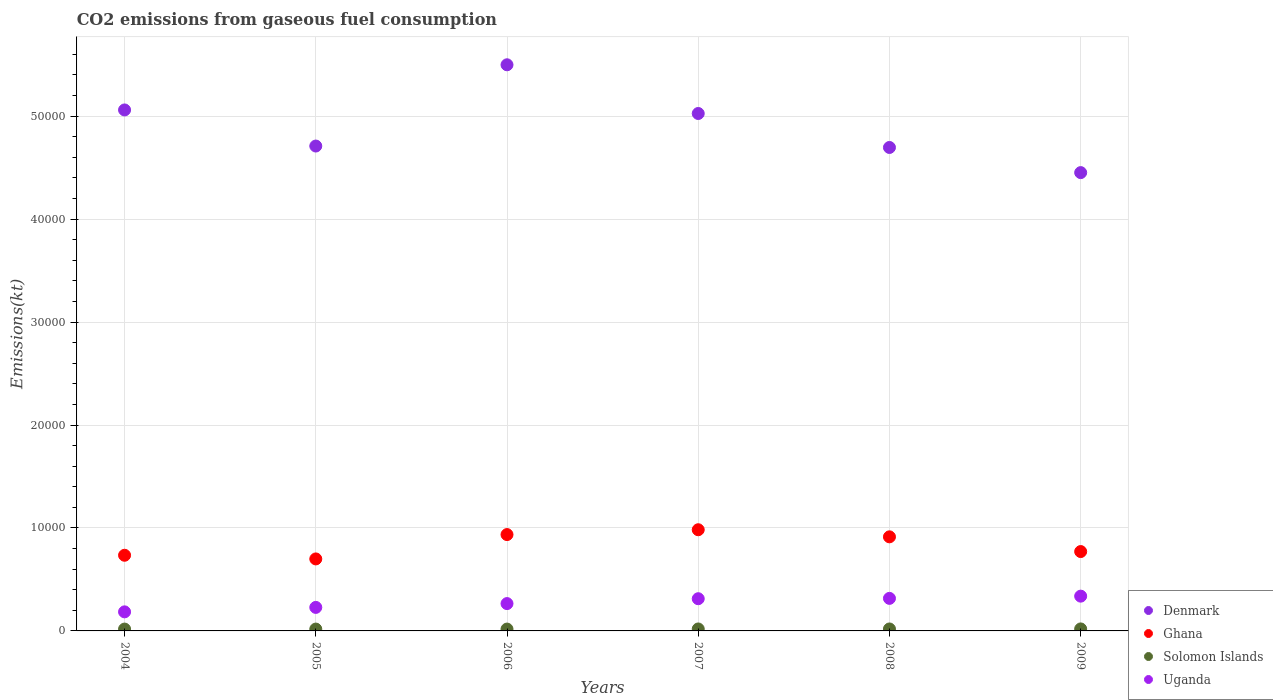How many different coloured dotlines are there?
Your response must be concise. 4. What is the amount of CO2 emitted in Solomon Islands in 2008?
Provide a short and direct response. 190.68. Across all years, what is the maximum amount of CO2 emitted in Uganda?
Ensure brevity in your answer.  3377.31. Across all years, what is the minimum amount of CO2 emitted in Uganda?
Ensure brevity in your answer.  1851.84. What is the total amount of CO2 emitted in Denmark in the graph?
Offer a very short reply. 2.94e+05. What is the difference between the amount of CO2 emitted in Denmark in 2006 and that in 2009?
Make the answer very short. 1.05e+04. What is the difference between the amount of CO2 emitted in Uganda in 2009 and the amount of CO2 emitted in Solomon Islands in 2007?
Offer a very short reply. 3186.62. What is the average amount of CO2 emitted in Denmark per year?
Give a very brief answer. 4.91e+04. In the year 2004, what is the difference between the amount of CO2 emitted in Uganda and amount of CO2 emitted in Denmark?
Provide a short and direct response. -4.87e+04. What is the ratio of the amount of CO2 emitted in Denmark in 2005 to that in 2006?
Your answer should be compact. 0.86. What is the difference between the highest and the second highest amount of CO2 emitted in Uganda?
Make the answer very short. 216.35. What is the difference between the highest and the lowest amount of CO2 emitted in Uganda?
Provide a succinct answer. 1525.47. In how many years, is the amount of CO2 emitted in Uganda greater than the average amount of CO2 emitted in Uganda taken over all years?
Offer a terse response. 3. Is it the case that in every year, the sum of the amount of CO2 emitted in Ghana and amount of CO2 emitted in Denmark  is greater than the sum of amount of CO2 emitted in Solomon Islands and amount of CO2 emitted in Uganda?
Your answer should be very brief. No. Is it the case that in every year, the sum of the amount of CO2 emitted in Solomon Islands and amount of CO2 emitted in Denmark  is greater than the amount of CO2 emitted in Ghana?
Give a very brief answer. Yes. Is the amount of CO2 emitted in Denmark strictly less than the amount of CO2 emitted in Solomon Islands over the years?
Offer a terse response. No. How many dotlines are there?
Ensure brevity in your answer.  4. What is the difference between two consecutive major ticks on the Y-axis?
Give a very brief answer. 10000. Does the graph contain any zero values?
Keep it short and to the point. No. Where does the legend appear in the graph?
Your answer should be compact. Bottom right. How many legend labels are there?
Your answer should be very brief. 4. How are the legend labels stacked?
Your response must be concise. Vertical. What is the title of the graph?
Provide a short and direct response. CO2 emissions from gaseous fuel consumption. Does "Ghana" appear as one of the legend labels in the graph?
Make the answer very short. Yes. What is the label or title of the X-axis?
Keep it short and to the point. Years. What is the label or title of the Y-axis?
Provide a succinct answer. Emissions(kt). What is the Emissions(kt) in Denmark in 2004?
Keep it short and to the point. 5.06e+04. What is the Emissions(kt) in Ghana in 2004?
Provide a succinct answer. 7348.67. What is the Emissions(kt) in Solomon Islands in 2004?
Offer a very short reply. 179.68. What is the Emissions(kt) of Uganda in 2004?
Keep it short and to the point. 1851.84. What is the Emissions(kt) of Denmark in 2005?
Provide a succinct answer. 4.71e+04. What is the Emissions(kt) in Ghana in 2005?
Ensure brevity in your answer.  6992.97. What is the Emissions(kt) of Solomon Islands in 2005?
Offer a very short reply. 179.68. What is the Emissions(kt) of Uganda in 2005?
Your answer should be compact. 2284.54. What is the Emissions(kt) of Denmark in 2006?
Ensure brevity in your answer.  5.50e+04. What is the Emissions(kt) of Ghana in 2006?
Your response must be concise. 9358.18. What is the Emissions(kt) in Solomon Islands in 2006?
Ensure brevity in your answer.  179.68. What is the Emissions(kt) of Uganda in 2006?
Give a very brief answer. 2654.91. What is the Emissions(kt) of Denmark in 2007?
Make the answer very short. 5.03e+04. What is the Emissions(kt) in Ghana in 2007?
Offer a terse response. 9827.56. What is the Emissions(kt) of Solomon Islands in 2007?
Make the answer very short. 190.68. What is the Emissions(kt) in Uganda in 2007?
Make the answer very short. 3127.95. What is the Emissions(kt) of Denmark in 2008?
Offer a very short reply. 4.70e+04. What is the Emissions(kt) in Ghana in 2008?
Make the answer very short. 9138.16. What is the Emissions(kt) in Solomon Islands in 2008?
Make the answer very short. 190.68. What is the Emissions(kt) in Uganda in 2008?
Your answer should be very brief. 3160.95. What is the Emissions(kt) in Denmark in 2009?
Give a very brief answer. 4.45e+04. What is the Emissions(kt) in Ghana in 2009?
Ensure brevity in your answer.  7708.03. What is the Emissions(kt) in Solomon Islands in 2009?
Make the answer very short. 194.35. What is the Emissions(kt) of Uganda in 2009?
Make the answer very short. 3377.31. Across all years, what is the maximum Emissions(kt) of Denmark?
Offer a very short reply. 5.50e+04. Across all years, what is the maximum Emissions(kt) in Ghana?
Your answer should be very brief. 9827.56. Across all years, what is the maximum Emissions(kt) of Solomon Islands?
Make the answer very short. 194.35. Across all years, what is the maximum Emissions(kt) in Uganda?
Provide a succinct answer. 3377.31. Across all years, what is the minimum Emissions(kt) in Denmark?
Provide a succinct answer. 4.45e+04. Across all years, what is the minimum Emissions(kt) of Ghana?
Give a very brief answer. 6992.97. Across all years, what is the minimum Emissions(kt) in Solomon Islands?
Provide a short and direct response. 179.68. Across all years, what is the minimum Emissions(kt) of Uganda?
Your answer should be compact. 1851.84. What is the total Emissions(kt) in Denmark in the graph?
Make the answer very short. 2.94e+05. What is the total Emissions(kt) of Ghana in the graph?
Give a very brief answer. 5.04e+04. What is the total Emissions(kt) of Solomon Islands in the graph?
Your response must be concise. 1114.77. What is the total Emissions(kt) of Uganda in the graph?
Make the answer very short. 1.65e+04. What is the difference between the Emissions(kt) in Denmark in 2004 and that in 2005?
Your answer should be compact. 3505.65. What is the difference between the Emissions(kt) of Ghana in 2004 and that in 2005?
Your answer should be compact. 355.7. What is the difference between the Emissions(kt) in Uganda in 2004 and that in 2005?
Make the answer very short. -432.71. What is the difference between the Emissions(kt) of Denmark in 2004 and that in 2006?
Keep it short and to the point. -4385.73. What is the difference between the Emissions(kt) in Ghana in 2004 and that in 2006?
Provide a succinct answer. -2009.52. What is the difference between the Emissions(kt) in Solomon Islands in 2004 and that in 2006?
Provide a short and direct response. 0. What is the difference between the Emissions(kt) of Uganda in 2004 and that in 2006?
Your answer should be compact. -803.07. What is the difference between the Emissions(kt) in Denmark in 2004 and that in 2007?
Your answer should be very brief. 344.7. What is the difference between the Emissions(kt) in Ghana in 2004 and that in 2007?
Give a very brief answer. -2478.89. What is the difference between the Emissions(kt) of Solomon Islands in 2004 and that in 2007?
Ensure brevity in your answer.  -11. What is the difference between the Emissions(kt) in Uganda in 2004 and that in 2007?
Make the answer very short. -1276.12. What is the difference between the Emissions(kt) of Denmark in 2004 and that in 2008?
Offer a very short reply. 3645. What is the difference between the Emissions(kt) of Ghana in 2004 and that in 2008?
Your answer should be very brief. -1789.5. What is the difference between the Emissions(kt) of Solomon Islands in 2004 and that in 2008?
Ensure brevity in your answer.  -11. What is the difference between the Emissions(kt) in Uganda in 2004 and that in 2008?
Offer a very short reply. -1309.12. What is the difference between the Emissions(kt) in Denmark in 2004 and that in 2009?
Give a very brief answer. 6087.22. What is the difference between the Emissions(kt) in Ghana in 2004 and that in 2009?
Give a very brief answer. -359.37. What is the difference between the Emissions(kt) in Solomon Islands in 2004 and that in 2009?
Give a very brief answer. -14.67. What is the difference between the Emissions(kt) in Uganda in 2004 and that in 2009?
Your answer should be compact. -1525.47. What is the difference between the Emissions(kt) in Denmark in 2005 and that in 2006?
Keep it short and to the point. -7891.38. What is the difference between the Emissions(kt) in Ghana in 2005 and that in 2006?
Provide a short and direct response. -2365.22. What is the difference between the Emissions(kt) of Uganda in 2005 and that in 2006?
Keep it short and to the point. -370.37. What is the difference between the Emissions(kt) of Denmark in 2005 and that in 2007?
Your response must be concise. -3160.95. What is the difference between the Emissions(kt) of Ghana in 2005 and that in 2007?
Provide a short and direct response. -2834.59. What is the difference between the Emissions(kt) of Solomon Islands in 2005 and that in 2007?
Ensure brevity in your answer.  -11. What is the difference between the Emissions(kt) in Uganda in 2005 and that in 2007?
Provide a short and direct response. -843.41. What is the difference between the Emissions(kt) in Denmark in 2005 and that in 2008?
Make the answer very short. 139.35. What is the difference between the Emissions(kt) in Ghana in 2005 and that in 2008?
Offer a terse response. -2145.2. What is the difference between the Emissions(kt) of Solomon Islands in 2005 and that in 2008?
Offer a terse response. -11. What is the difference between the Emissions(kt) in Uganda in 2005 and that in 2008?
Make the answer very short. -876.41. What is the difference between the Emissions(kt) of Denmark in 2005 and that in 2009?
Ensure brevity in your answer.  2581.57. What is the difference between the Emissions(kt) in Ghana in 2005 and that in 2009?
Offer a very short reply. -715.07. What is the difference between the Emissions(kt) of Solomon Islands in 2005 and that in 2009?
Give a very brief answer. -14.67. What is the difference between the Emissions(kt) of Uganda in 2005 and that in 2009?
Offer a terse response. -1092.77. What is the difference between the Emissions(kt) of Denmark in 2006 and that in 2007?
Make the answer very short. 4730.43. What is the difference between the Emissions(kt) of Ghana in 2006 and that in 2007?
Keep it short and to the point. -469.38. What is the difference between the Emissions(kt) in Solomon Islands in 2006 and that in 2007?
Offer a very short reply. -11. What is the difference between the Emissions(kt) of Uganda in 2006 and that in 2007?
Your response must be concise. -473.04. What is the difference between the Emissions(kt) in Denmark in 2006 and that in 2008?
Provide a short and direct response. 8030.73. What is the difference between the Emissions(kt) in Ghana in 2006 and that in 2008?
Offer a terse response. 220.02. What is the difference between the Emissions(kt) of Solomon Islands in 2006 and that in 2008?
Make the answer very short. -11. What is the difference between the Emissions(kt) in Uganda in 2006 and that in 2008?
Offer a terse response. -506.05. What is the difference between the Emissions(kt) in Denmark in 2006 and that in 2009?
Offer a very short reply. 1.05e+04. What is the difference between the Emissions(kt) of Ghana in 2006 and that in 2009?
Offer a terse response. 1650.15. What is the difference between the Emissions(kt) in Solomon Islands in 2006 and that in 2009?
Give a very brief answer. -14.67. What is the difference between the Emissions(kt) of Uganda in 2006 and that in 2009?
Provide a succinct answer. -722.4. What is the difference between the Emissions(kt) of Denmark in 2007 and that in 2008?
Your answer should be very brief. 3300.3. What is the difference between the Emissions(kt) of Ghana in 2007 and that in 2008?
Offer a very short reply. 689.4. What is the difference between the Emissions(kt) in Uganda in 2007 and that in 2008?
Offer a terse response. -33. What is the difference between the Emissions(kt) in Denmark in 2007 and that in 2009?
Your response must be concise. 5742.52. What is the difference between the Emissions(kt) in Ghana in 2007 and that in 2009?
Provide a succinct answer. 2119.53. What is the difference between the Emissions(kt) in Solomon Islands in 2007 and that in 2009?
Your answer should be compact. -3.67. What is the difference between the Emissions(kt) in Uganda in 2007 and that in 2009?
Your answer should be compact. -249.36. What is the difference between the Emissions(kt) in Denmark in 2008 and that in 2009?
Make the answer very short. 2442.22. What is the difference between the Emissions(kt) in Ghana in 2008 and that in 2009?
Your response must be concise. 1430.13. What is the difference between the Emissions(kt) of Solomon Islands in 2008 and that in 2009?
Offer a terse response. -3.67. What is the difference between the Emissions(kt) in Uganda in 2008 and that in 2009?
Keep it short and to the point. -216.35. What is the difference between the Emissions(kt) of Denmark in 2004 and the Emissions(kt) of Ghana in 2005?
Your answer should be very brief. 4.36e+04. What is the difference between the Emissions(kt) in Denmark in 2004 and the Emissions(kt) in Solomon Islands in 2005?
Your answer should be very brief. 5.04e+04. What is the difference between the Emissions(kt) of Denmark in 2004 and the Emissions(kt) of Uganda in 2005?
Offer a terse response. 4.83e+04. What is the difference between the Emissions(kt) of Ghana in 2004 and the Emissions(kt) of Solomon Islands in 2005?
Keep it short and to the point. 7168.98. What is the difference between the Emissions(kt) in Ghana in 2004 and the Emissions(kt) in Uganda in 2005?
Offer a very short reply. 5064.13. What is the difference between the Emissions(kt) of Solomon Islands in 2004 and the Emissions(kt) of Uganda in 2005?
Ensure brevity in your answer.  -2104.86. What is the difference between the Emissions(kt) in Denmark in 2004 and the Emissions(kt) in Ghana in 2006?
Ensure brevity in your answer.  4.12e+04. What is the difference between the Emissions(kt) in Denmark in 2004 and the Emissions(kt) in Solomon Islands in 2006?
Your answer should be very brief. 5.04e+04. What is the difference between the Emissions(kt) in Denmark in 2004 and the Emissions(kt) in Uganda in 2006?
Provide a short and direct response. 4.79e+04. What is the difference between the Emissions(kt) of Ghana in 2004 and the Emissions(kt) of Solomon Islands in 2006?
Your answer should be very brief. 7168.98. What is the difference between the Emissions(kt) in Ghana in 2004 and the Emissions(kt) in Uganda in 2006?
Offer a terse response. 4693.76. What is the difference between the Emissions(kt) of Solomon Islands in 2004 and the Emissions(kt) of Uganda in 2006?
Your answer should be very brief. -2475.22. What is the difference between the Emissions(kt) in Denmark in 2004 and the Emissions(kt) in Ghana in 2007?
Keep it short and to the point. 4.08e+04. What is the difference between the Emissions(kt) of Denmark in 2004 and the Emissions(kt) of Solomon Islands in 2007?
Your answer should be very brief. 5.04e+04. What is the difference between the Emissions(kt) of Denmark in 2004 and the Emissions(kt) of Uganda in 2007?
Your answer should be compact. 4.75e+04. What is the difference between the Emissions(kt) of Ghana in 2004 and the Emissions(kt) of Solomon Islands in 2007?
Offer a very short reply. 7157.98. What is the difference between the Emissions(kt) of Ghana in 2004 and the Emissions(kt) of Uganda in 2007?
Give a very brief answer. 4220.72. What is the difference between the Emissions(kt) in Solomon Islands in 2004 and the Emissions(kt) in Uganda in 2007?
Keep it short and to the point. -2948.27. What is the difference between the Emissions(kt) in Denmark in 2004 and the Emissions(kt) in Ghana in 2008?
Your response must be concise. 4.15e+04. What is the difference between the Emissions(kt) in Denmark in 2004 and the Emissions(kt) in Solomon Islands in 2008?
Keep it short and to the point. 5.04e+04. What is the difference between the Emissions(kt) of Denmark in 2004 and the Emissions(kt) of Uganda in 2008?
Provide a succinct answer. 4.74e+04. What is the difference between the Emissions(kt) of Ghana in 2004 and the Emissions(kt) of Solomon Islands in 2008?
Your response must be concise. 7157.98. What is the difference between the Emissions(kt) of Ghana in 2004 and the Emissions(kt) of Uganda in 2008?
Your answer should be compact. 4187.71. What is the difference between the Emissions(kt) of Solomon Islands in 2004 and the Emissions(kt) of Uganda in 2008?
Provide a succinct answer. -2981.27. What is the difference between the Emissions(kt) in Denmark in 2004 and the Emissions(kt) in Ghana in 2009?
Your answer should be very brief. 4.29e+04. What is the difference between the Emissions(kt) of Denmark in 2004 and the Emissions(kt) of Solomon Islands in 2009?
Your answer should be compact. 5.04e+04. What is the difference between the Emissions(kt) of Denmark in 2004 and the Emissions(kt) of Uganda in 2009?
Offer a very short reply. 4.72e+04. What is the difference between the Emissions(kt) of Ghana in 2004 and the Emissions(kt) of Solomon Islands in 2009?
Provide a succinct answer. 7154.32. What is the difference between the Emissions(kt) in Ghana in 2004 and the Emissions(kt) in Uganda in 2009?
Provide a short and direct response. 3971.36. What is the difference between the Emissions(kt) of Solomon Islands in 2004 and the Emissions(kt) of Uganda in 2009?
Make the answer very short. -3197.62. What is the difference between the Emissions(kt) of Denmark in 2005 and the Emissions(kt) of Ghana in 2006?
Make the answer very short. 3.77e+04. What is the difference between the Emissions(kt) of Denmark in 2005 and the Emissions(kt) of Solomon Islands in 2006?
Provide a succinct answer. 4.69e+04. What is the difference between the Emissions(kt) in Denmark in 2005 and the Emissions(kt) in Uganda in 2006?
Provide a short and direct response. 4.44e+04. What is the difference between the Emissions(kt) in Ghana in 2005 and the Emissions(kt) in Solomon Islands in 2006?
Offer a very short reply. 6813.29. What is the difference between the Emissions(kt) in Ghana in 2005 and the Emissions(kt) in Uganda in 2006?
Keep it short and to the point. 4338.06. What is the difference between the Emissions(kt) in Solomon Islands in 2005 and the Emissions(kt) in Uganda in 2006?
Provide a short and direct response. -2475.22. What is the difference between the Emissions(kt) of Denmark in 2005 and the Emissions(kt) of Ghana in 2007?
Provide a short and direct response. 3.73e+04. What is the difference between the Emissions(kt) in Denmark in 2005 and the Emissions(kt) in Solomon Islands in 2007?
Provide a succinct answer. 4.69e+04. What is the difference between the Emissions(kt) in Denmark in 2005 and the Emissions(kt) in Uganda in 2007?
Your answer should be compact. 4.40e+04. What is the difference between the Emissions(kt) of Ghana in 2005 and the Emissions(kt) of Solomon Islands in 2007?
Provide a succinct answer. 6802.28. What is the difference between the Emissions(kt) in Ghana in 2005 and the Emissions(kt) in Uganda in 2007?
Offer a very short reply. 3865.02. What is the difference between the Emissions(kt) in Solomon Islands in 2005 and the Emissions(kt) in Uganda in 2007?
Make the answer very short. -2948.27. What is the difference between the Emissions(kt) in Denmark in 2005 and the Emissions(kt) in Ghana in 2008?
Provide a succinct answer. 3.80e+04. What is the difference between the Emissions(kt) in Denmark in 2005 and the Emissions(kt) in Solomon Islands in 2008?
Give a very brief answer. 4.69e+04. What is the difference between the Emissions(kt) of Denmark in 2005 and the Emissions(kt) of Uganda in 2008?
Give a very brief answer. 4.39e+04. What is the difference between the Emissions(kt) in Ghana in 2005 and the Emissions(kt) in Solomon Islands in 2008?
Keep it short and to the point. 6802.28. What is the difference between the Emissions(kt) in Ghana in 2005 and the Emissions(kt) in Uganda in 2008?
Provide a succinct answer. 3832.01. What is the difference between the Emissions(kt) in Solomon Islands in 2005 and the Emissions(kt) in Uganda in 2008?
Give a very brief answer. -2981.27. What is the difference between the Emissions(kt) of Denmark in 2005 and the Emissions(kt) of Ghana in 2009?
Your response must be concise. 3.94e+04. What is the difference between the Emissions(kt) of Denmark in 2005 and the Emissions(kt) of Solomon Islands in 2009?
Ensure brevity in your answer.  4.69e+04. What is the difference between the Emissions(kt) of Denmark in 2005 and the Emissions(kt) of Uganda in 2009?
Give a very brief answer. 4.37e+04. What is the difference between the Emissions(kt) of Ghana in 2005 and the Emissions(kt) of Solomon Islands in 2009?
Ensure brevity in your answer.  6798.62. What is the difference between the Emissions(kt) of Ghana in 2005 and the Emissions(kt) of Uganda in 2009?
Offer a terse response. 3615.66. What is the difference between the Emissions(kt) in Solomon Islands in 2005 and the Emissions(kt) in Uganda in 2009?
Your answer should be very brief. -3197.62. What is the difference between the Emissions(kt) of Denmark in 2006 and the Emissions(kt) of Ghana in 2007?
Offer a very short reply. 4.52e+04. What is the difference between the Emissions(kt) in Denmark in 2006 and the Emissions(kt) in Solomon Islands in 2007?
Offer a very short reply. 5.48e+04. What is the difference between the Emissions(kt) of Denmark in 2006 and the Emissions(kt) of Uganda in 2007?
Provide a succinct answer. 5.19e+04. What is the difference between the Emissions(kt) of Ghana in 2006 and the Emissions(kt) of Solomon Islands in 2007?
Your answer should be compact. 9167.5. What is the difference between the Emissions(kt) in Ghana in 2006 and the Emissions(kt) in Uganda in 2007?
Your response must be concise. 6230.23. What is the difference between the Emissions(kt) of Solomon Islands in 2006 and the Emissions(kt) of Uganda in 2007?
Offer a very short reply. -2948.27. What is the difference between the Emissions(kt) of Denmark in 2006 and the Emissions(kt) of Ghana in 2008?
Ensure brevity in your answer.  4.58e+04. What is the difference between the Emissions(kt) in Denmark in 2006 and the Emissions(kt) in Solomon Islands in 2008?
Your answer should be very brief. 5.48e+04. What is the difference between the Emissions(kt) of Denmark in 2006 and the Emissions(kt) of Uganda in 2008?
Offer a terse response. 5.18e+04. What is the difference between the Emissions(kt) in Ghana in 2006 and the Emissions(kt) in Solomon Islands in 2008?
Your response must be concise. 9167.5. What is the difference between the Emissions(kt) in Ghana in 2006 and the Emissions(kt) in Uganda in 2008?
Your answer should be compact. 6197.23. What is the difference between the Emissions(kt) of Solomon Islands in 2006 and the Emissions(kt) of Uganda in 2008?
Your response must be concise. -2981.27. What is the difference between the Emissions(kt) of Denmark in 2006 and the Emissions(kt) of Ghana in 2009?
Offer a terse response. 4.73e+04. What is the difference between the Emissions(kt) of Denmark in 2006 and the Emissions(kt) of Solomon Islands in 2009?
Your answer should be compact. 5.48e+04. What is the difference between the Emissions(kt) in Denmark in 2006 and the Emissions(kt) in Uganda in 2009?
Your answer should be compact. 5.16e+04. What is the difference between the Emissions(kt) of Ghana in 2006 and the Emissions(kt) of Solomon Islands in 2009?
Your answer should be very brief. 9163.83. What is the difference between the Emissions(kt) of Ghana in 2006 and the Emissions(kt) of Uganda in 2009?
Provide a short and direct response. 5980.88. What is the difference between the Emissions(kt) of Solomon Islands in 2006 and the Emissions(kt) of Uganda in 2009?
Your answer should be compact. -3197.62. What is the difference between the Emissions(kt) of Denmark in 2007 and the Emissions(kt) of Ghana in 2008?
Provide a short and direct response. 4.11e+04. What is the difference between the Emissions(kt) of Denmark in 2007 and the Emissions(kt) of Solomon Islands in 2008?
Provide a short and direct response. 5.01e+04. What is the difference between the Emissions(kt) in Denmark in 2007 and the Emissions(kt) in Uganda in 2008?
Your response must be concise. 4.71e+04. What is the difference between the Emissions(kt) in Ghana in 2007 and the Emissions(kt) in Solomon Islands in 2008?
Your answer should be very brief. 9636.88. What is the difference between the Emissions(kt) in Ghana in 2007 and the Emissions(kt) in Uganda in 2008?
Your answer should be very brief. 6666.61. What is the difference between the Emissions(kt) of Solomon Islands in 2007 and the Emissions(kt) of Uganda in 2008?
Provide a succinct answer. -2970.27. What is the difference between the Emissions(kt) of Denmark in 2007 and the Emissions(kt) of Ghana in 2009?
Ensure brevity in your answer.  4.25e+04. What is the difference between the Emissions(kt) of Denmark in 2007 and the Emissions(kt) of Solomon Islands in 2009?
Ensure brevity in your answer.  5.01e+04. What is the difference between the Emissions(kt) in Denmark in 2007 and the Emissions(kt) in Uganda in 2009?
Make the answer very short. 4.69e+04. What is the difference between the Emissions(kt) of Ghana in 2007 and the Emissions(kt) of Solomon Islands in 2009?
Keep it short and to the point. 9633.21. What is the difference between the Emissions(kt) in Ghana in 2007 and the Emissions(kt) in Uganda in 2009?
Your response must be concise. 6450.25. What is the difference between the Emissions(kt) in Solomon Islands in 2007 and the Emissions(kt) in Uganda in 2009?
Your response must be concise. -3186.62. What is the difference between the Emissions(kt) in Denmark in 2008 and the Emissions(kt) in Ghana in 2009?
Make the answer very short. 3.92e+04. What is the difference between the Emissions(kt) in Denmark in 2008 and the Emissions(kt) in Solomon Islands in 2009?
Make the answer very short. 4.68e+04. What is the difference between the Emissions(kt) in Denmark in 2008 and the Emissions(kt) in Uganda in 2009?
Your answer should be very brief. 4.36e+04. What is the difference between the Emissions(kt) in Ghana in 2008 and the Emissions(kt) in Solomon Islands in 2009?
Your answer should be compact. 8943.81. What is the difference between the Emissions(kt) of Ghana in 2008 and the Emissions(kt) of Uganda in 2009?
Give a very brief answer. 5760.86. What is the difference between the Emissions(kt) of Solomon Islands in 2008 and the Emissions(kt) of Uganda in 2009?
Ensure brevity in your answer.  -3186.62. What is the average Emissions(kt) in Denmark per year?
Provide a short and direct response. 4.91e+04. What is the average Emissions(kt) in Ghana per year?
Offer a terse response. 8395.6. What is the average Emissions(kt) in Solomon Islands per year?
Your response must be concise. 185.79. What is the average Emissions(kt) of Uganda per year?
Offer a terse response. 2742.92. In the year 2004, what is the difference between the Emissions(kt) of Denmark and Emissions(kt) of Ghana?
Your answer should be compact. 4.33e+04. In the year 2004, what is the difference between the Emissions(kt) in Denmark and Emissions(kt) in Solomon Islands?
Your answer should be very brief. 5.04e+04. In the year 2004, what is the difference between the Emissions(kt) in Denmark and Emissions(kt) in Uganda?
Your response must be concise. 4.87e+04. In the year 2004, what is the difference between the Emissions(kt) in Ghana and Emissions(kt) in Solomon Islands?
Your answer should be very brief. 7168.98. In the year 2004, what is the difference between the Emissions(kt) in Ghana and Emissions(kt) in Uganda?
Offer a terse response. 5496.83. In the year 2004, what is the difference between the Emissions(kt) in Solomon Islands and Emissions(kt) in Uganda?
Your answer should be very brief. -1672.15. In the year 2005, what is the difference between the Emissions(kt) in Denmark and Emissions(kt) in Ghana?
Provide a short and direct response. 4.01e+04. In the year 2005, what is the difference between the Emissions(kt) of Denmark and Emissions(kt) of Solomon Islands?
Keep it short and to the point. 4.69e+04. In the year 2005, what is the difference between the Emissions(kt) of Denmark and Emissions(kt) of Uganda?
Your response must be concise. 4.48e+04. In the year 2005, what is the difference between the Emissions(kt) of Ghana and Emissions(kt) of Solomon Islands?
Keep it short and to the point. 6813.29. In the year 2005, what is the difference between the Emissions(kt) in Ghana and Emissions(kt) in Uganda?
Your answer should be very brief. 4708.43. In the year 2005, what is the difference between the Emissions(kt) in Solomon Islands and Emissions(kt) in Uganda?
Ensure brevity in your answer.  -2104.86. In the year 2006, what is the difference between the Emissions(kt) in Denmark and Emissions(kt) in Ghana?
Give a very brief answer. 4.56e+04. In the year 2006, what is the difference between the Emissions(kt) in Denmark and Emissions(kt) in Solomon Islands?
Ensure brevity in your answer.  5.48e+04. In the year 2006, what is the difference between the Emissions(kt) of Denmark and Emissions(kt) of Uganda?
Ensure brevity in your answer.  5.23e+04. In the year 2006, what is the difference between the Emissions(kt) of Ghana and Emissions(kt) of Solomon Islands?
Your answer should be very brief. 9178.5. In the year 2006, what is the difference between the Emissions(kt) in Ghana and Emissions(kt) in Uganda?
Make the answer very short. 6703.28. In the year 2006, what is the difference between the Emissions(kt) of Solomon Islands and Emissions(kt) of Uganda?
Keep it short and to the point. -2475.22. In the year 2007, what is the difference between the Emissions(kt) of Denmark and Emissions(kt) of Ghana?
Your answer should be compact. 4.04e+04. In the year 2007, what is the difference between the Emissions(kt) of Denmark and Emissions(kt) of Solomon Islands?
Your answer should be compact. 5.01e+04. In the year 2007, what is the difference between the Emissions(kt) in Denmark and Emissions(kt) in Uganda?
Provide a short and direct response. 4.71e+04. In the year 2007, what is the difference between the Emissions(kt) in Ghana and Emissions(kt) in Solomon Islands?
Offer a very short reply. 9636.88. In the year 2007, what is the difference between the Emissions(kt) in Ghana and Emissions(kt) in Uganda?
Provide a short and direct response. 6699.61. In the year 2007, what is the difference between the Emissions(kt) of Solomon Islands and Emissions(kt) of Uganda?
Your answer should be very brief. -2937.27. In the year 2008, what is the difference between the Emissions(kt) in Denmark and Emissions(kt) in Ghana?
Your answer should be very brief. 3.78e+04. In the year 2008, what is the difference between the Emissions(kt) of Denmark and Emissions(kt) of Solomon Islands?
Keep it short and to the point. 4.68e+04. In the year 2008, what is the difference between the Emissions(kt) in Denmark and Emissions(kt) in Uganda?
Your answer should be very brief. 4.38e+04. In the year 2008, what is the difference between the Emissions(kt) of Ghana and Emissions(kt) of Solomon Islands?
Give a very brief answer. 8947.48. In the year 2008, what is the difference between the Emissions(kt) of Ghana and Emissions(kt) of Uganda?
Keep it short and to the point. 5977.21. In the year 2008, what is the difference between the Emissions(kt) of Solomon Islands and Emissions(kt) of Uganda?
Make the answer very short. -2970.27. In the year 2009, what is the difference between the Emissions(kt) of Denmark and Emissions(kt) of Ghana?
Your answer should be very brief. 3.68e+04. In the year 2009, what is the difference between the Emissions(kt) in Denmark and Emissions(kt) in Solomon Islands?
Offer a very short reply. 4.43e+04. In the year 2009, what is the difference between the Emissions(kt) in Denmark and Emissions(kt) in Uganda?
Provide a short and direct response. 4.11e+04. In the year 2009, what is the difference between the Emissions(kt) in Ghana and Emissions(kt) in Solomon Islands?
Your response must be concise. 7513.68. In the year 2009, what is the difference between the Emissions(kt) of Ghana and Emissions(kt) of Uganda?
Your answer should be compact. 4330.73. In the year 2009, what is the difference between the Emissions(kt) in Solomon Islands and Emissions(kt) in Uganda?
Your answer should be compact. -3182.96. What is the ratio of the Emissions(kt) of Denmark in 2004 to that in 2005?
Your response must be concise. 1.07. What is the ratio of the Emissions(kt) in Ghana in 2004 to that in 2005?
Ensure brevity in your answer.  1.05. What is the ratio of the Emissions(kt) in Solomon Islands in 2004 to that in 2005?
Offer a terse response. 1. What is the ratio of the Emissions(kt) of Uganda in 2004 to that in 2005?
Keep it short and to the point. 0.81. What is the ratio of the Emissions(kt) of Denmark in 2004 to that in 2006?
Provide a succinct answer. 0.92. What is the ratio of the Emissions(kt) in Ghana in 2004 to that in 2006?
Make the answer very short. 0.79. What is the ratio of the Emissions(kt) of Solomon Islands in 2004 to that in 2006?
Ensure brevity in your answer.  1. What is the ratio of the Emissions(kt) of Uganda in 2004 to that in 2006?
Provide a short and direct response. 0.7. What is the ratio of the Emissions(kt) in Ghana in 2004 to that in 2007?
Make the answer very short. 0.75. What is the ratio of the Emissions(kt) of Solomon Islands in 2004 to that in 2007?
Your response must be concise. 0.94. What is the ratio of the Emissions(kt) in Uganda in 2004 to that in 2007?
Give a very brief answer. 0.59. What is the ratio of the Emissions(kt) in Denmark in 2004 to that in 2008?
Keep it short and to the point. 1.08. What is the ratio of the Emissions(kt) of Ghana in 2004 to that in 2008?
Keep it short and to the point. 0.8. What is the ratio of the Emissions(kt) of Solomon Islands in 2004 to that in 2008?
Provide a short and direct response. 0.94. What is the ratio of the Emissions(kt) of Uganda in 2004 to that in 2008?
Keep it short and to the point. 0.59. What is the ratio of the Emissions(kt) in Denmark in 2004 to that in 2009?
Give a very brief answer. 1.14. What is the ratio of the Emissions(kt) in Ghana in 2004 to that in 2009?
Your answer should be very brief. 0.95. What is the ratio of the Emissions(kt) of Solomon Islands in 2004 to that in 2009?
Ensure brevity in your answer.  0.92. What is the ratio of the Emissions(kt) in Uganda in 2004 to that in 2009?
Your answer should be compact. 0.55. What is the ratio of the Emissions(kt) in Denmark in 2005 to that in 2006?
Keep it short and to the point. 0.86. What is the ratio of the Emissions(kt) of Ghana in 2005 to that in 2006?
Make the answer very short. 0.75. What is the ratio of the Emissions(kt) in Uganda in 2005 to that in 2006?
Offer a terse response. 0.86. What is the ratio of the Emissions(kt) of Denmark in 2005 to that in 2007?
Your answer should be compact. 0.94. What is the ratio of the Emissions(kt) of Ghana in 2005 to that in 2007?
Offer a very short reply. 0.71. What is the ratio of the Emissions(kt) of Solomon Islands in 2005 to that in 2007?
Provide a short and direct response. 0.94. What is the ratio of the Emissions(kt) of Uganda in 2005 to that in 2007?
Offer a very short reply. 0.73. What is the ratio of the Emissions(kt) of Ghana in 2005 to that in 2008?
Provide a succinct answer. 0.77. What is the ratio of the Emissions(kt) of Solomon Islands in 2005 to that in 2008?
Your answer should be compact. 0.94. What is the ratio of the Emissions(kt) in Uganda in 2005 to that in 2008?
Your answer should be compact. 0.72. What is the ratio of the Emissions(kt) of Denmark in 2005 to that in 2009?
Your response must be concise. 1.06. What is the ratio of the Emissions(kt) in Ghana in 2005 to that in 2009?
Offer a terse response. 0.91. What is the ratio of the Emissions(kt) of Solomon Islands in 2005 to that in 2009?
Keep it short and to the point. 0.92. What is the ratio of the Emissions(kt) of Uganda in 2005 to that in 2009?
Your answer should be compact. 0.68. What is the ratio of the Emissions(kt) in Denmark in 2006 to that in 2007?
Keep it short and to the point. 1.09. What is the ratio of the Emissions(kt) in Ghana in 2006 to that in 2007?
Your answer should be compact. 0.95. What is the ratio of the Emissions(kt) of Solomon Islands in 2006 to that in 2007?
Provide a short and direct response. 0.94. What is the ratio of the Emissions(kt) of Uganda in 2006 to that in 2007?
Your answer should be compact. 0.85. What is the ratio of the Emissions(kt) of Denmark in 2006 to that in 2008?
Provide a short and direct response. 1.17. What is the ratio of the Emissions(kt) of Ghana in 2006 to that in 2008?
Keep it short and to the point. 1.02. What is the ratio of the Emissions(kt) of Solomon Islands in 2006 to that in 2008?
Give a very brief answer. 0.94. What is the ratio of the Emissions(kt) in Uganda in 2006 to that in 2008?
Your response must be concise. 0.84. What is the ratio of the Emissions(kt) in Denmark in 2006 to that in 2009?
Your answer should be very brief. 1.24. What is the ratio of the Emissions(kt) in Ghana in 2006 to that in 2009?
Ensure brevity in your answer.  1.21. What is the ratio of the Emissions(kt) in Solomon Islands in 2006 to that in 2009?
Keep it short and to the point. 0.92. What is the ratio of the Emissions(kt) in Uganda in 2006 to that in 2009?
Your answer should be compact. 0.79. What is the ratio of the Emissions(kt) in Denmark in 2007 to that in 2008?
Give a very brief answer. 1.07. What is the ratio of the Emissions(kt) in Ghana in 2007 to that in 2008?
Provide a succinct answer. 1.08. What is the ratio of the Emissions(kt) of Denmark in 2007 to that in 2009?
Your answer should be very brief. 1.13. What is the ratio of the Emissions(kt) of Ghana in 2007 to that in 2009?
Your answer should be compact. 1.27. What is the ratio of the Emissions(kt) of Solomon Islands in 2007 to that in 2009?
Make the answer very short. 0.98. What is the ratio of the Emissions(kt) of Uganda in 2007 to that in 2009?
Make the answer very short. 0.93. What is the ratio of the Emissions(kt) of Denmark in 2008 to that in 2009?
Your response must be concise. 1.05. What is the ratio of the Emissions(kt) of Ghana in 2008 to that in 2009?
Offer a very short reply. 1.19. What is the ratio of the Emissions(kt) of Solomon Islands in 2008 to that in 2009?
Provide a succinct answer. 0.98. What is the ratio of the Emissions(kt) of Uganda in 2008 to that in 2009?
Offer a terse response. 0.94. What is the difference between the highest and the second highest Emissions(kt) of Denmark?
Make the answer very short. 4385.73. What is the difference between the highest and the second highest Emissions(kt) in Ghana?
Offer a terse response. 469.38. What is the difference between the highest and the second highest Emissions(kt) of Solomon Islands?
Provide a short and direct response. 3.67. What is the difference between the highest and the second highest Emissions(kt) of Uganda?
Offer a very short reply. 216.35. What is the difference between the highest and the lowest Emissions(kt) of Denmark?
Offer a very short reply. 1.05e+04. What is the difference between the highest and the lowest Emissions(kt) of Ghana?
Your response must be concise. 2834.59. What is the difference between the highest and the lowest Emissions(kt) of Solomon Islands?
Provide a short and direct response. 14.67. What is the difference between the highest and the lowest Emissions(kt) in Uganda?
Keep it short and to the point. 1525.47. 